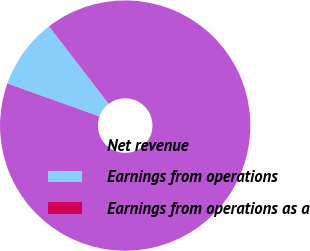Convert chart to OTSL. <chart><loc_0><loc_0><loc_500><loc_500><pie_chart><fcel>Net revenue<fcel>Earnings from operations<fcel>Earnings from operations as a<nl><fcel>90.88%<fcel>9.1%<fcel>0.02%<nl></chart> 